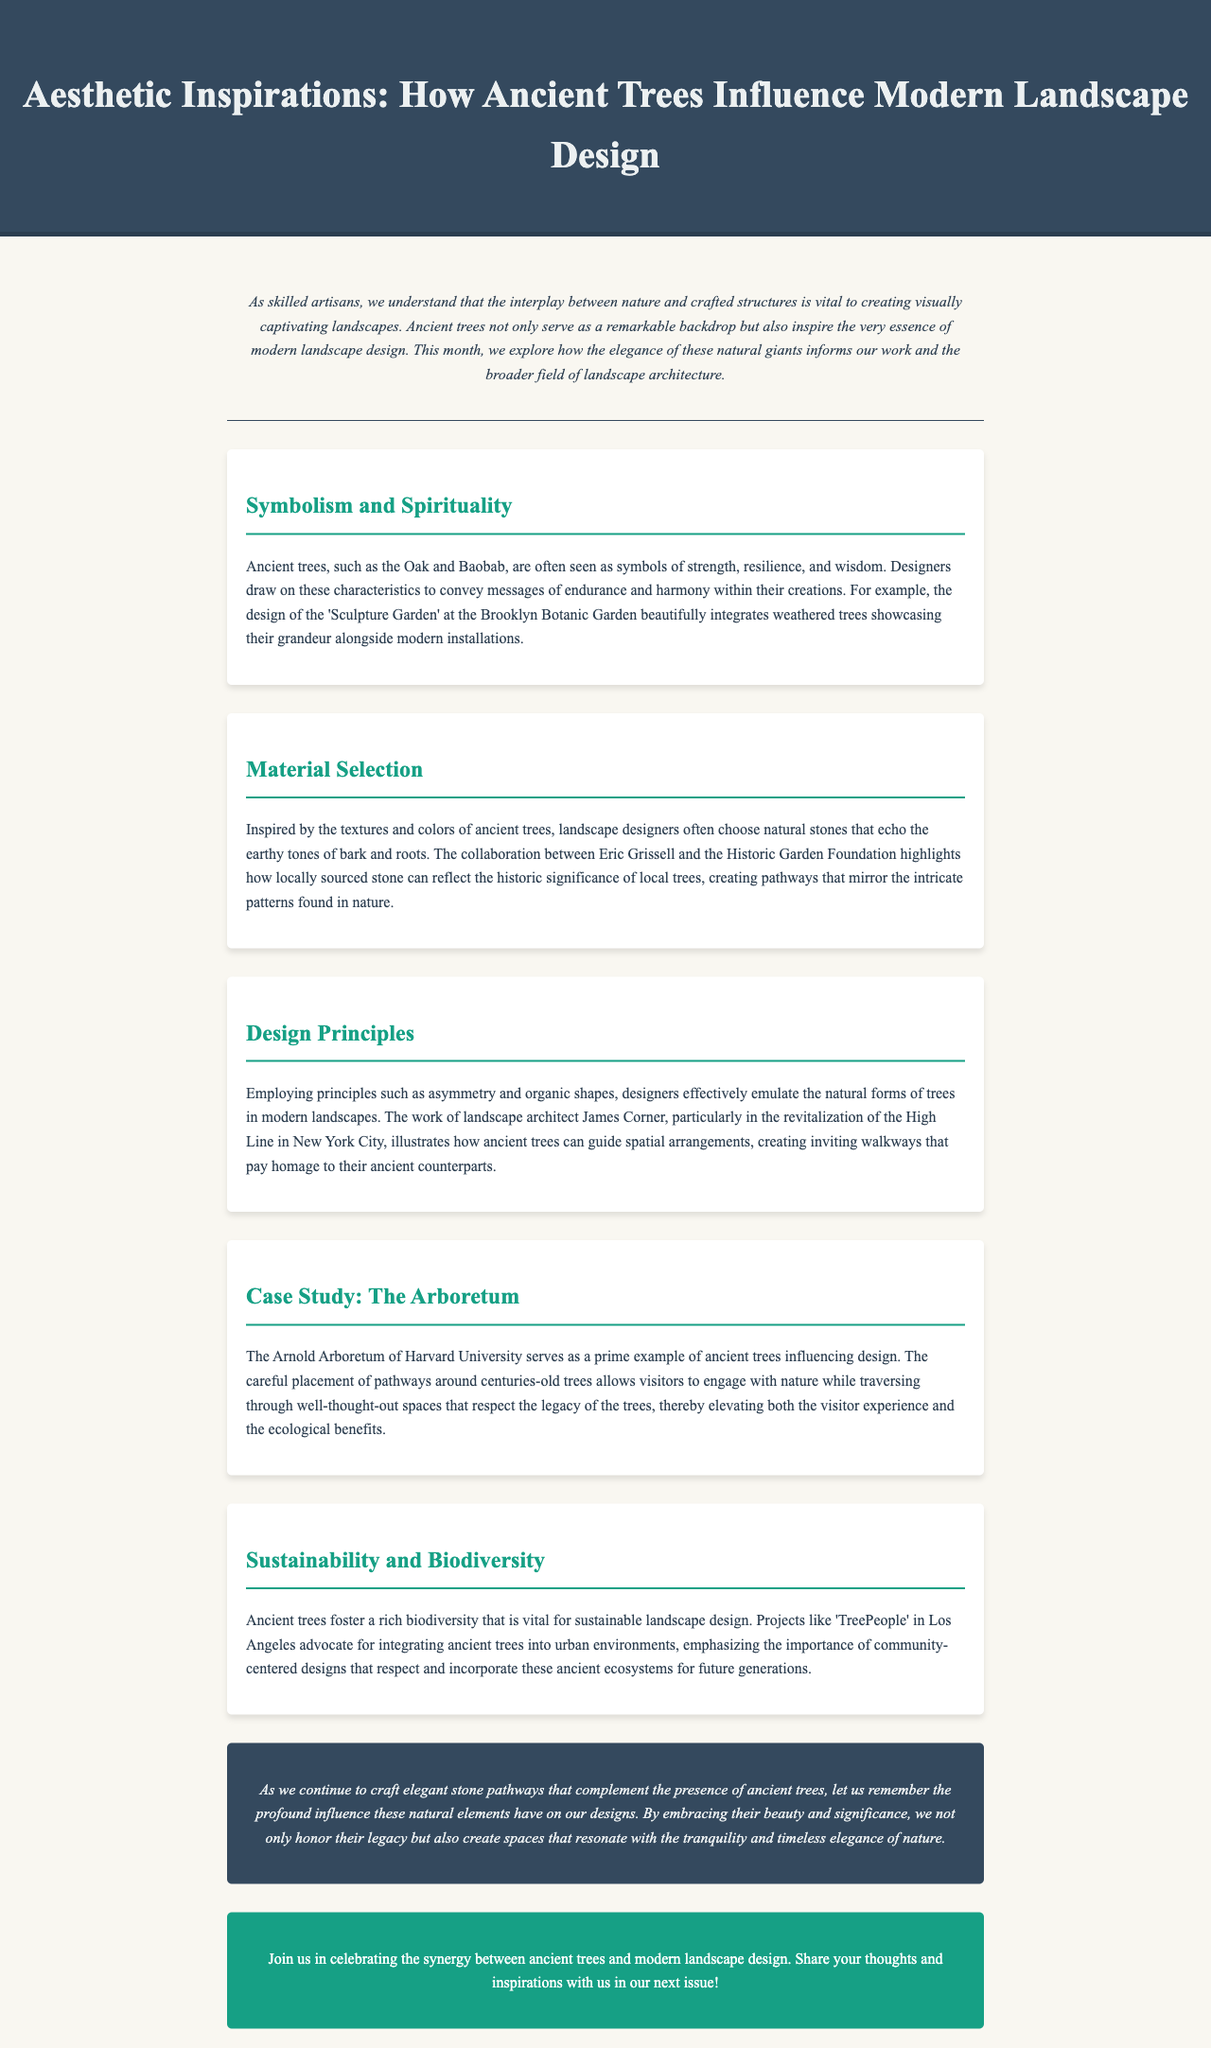What is the title of the newsletter? The title is found at the top of the document under the header section.
Answer: Aesthetic Inspirations: How Ancient Trees Influence Modern Landscape Design What are ancient trees often seen as symbols of? This information can be found in the section discussing symbolism and spirituality.
Answer: Strength, resilience, and wisdom Which landscape architect is mentioned in the document? The reference can be found in the Design Principles section discussing specific works.
Answer: James Corner What project advocates for integrating ancient trees into urban environments? The project is specifically referenced in the Sustainability and Biodiversity section.
Answer: TreePeople What does the Arnold Arboretum serve as a prime example of? This is outlined in the case study section highlighting the role of ancient trees.
Answer: Ancient trees influencing design How do ancient trees contribute to sustainable landscape design? This is explained in the context of biodiversity in the Sustainability and Biodiversity section.
Answer: Foster rich biodiversity What type of materials do landscape designers choose inspired by ancient trees? This is detailed in the Material Selection section, which discusses the type of materials used.
Answer: Natural stones What is the overarching purpose of the newsletter? The purpose is summarised in the introduction, highlighting the relationship between nature and crafted structures.
Answer: To explore how the elegance of ancient trees informs modern landscape design 